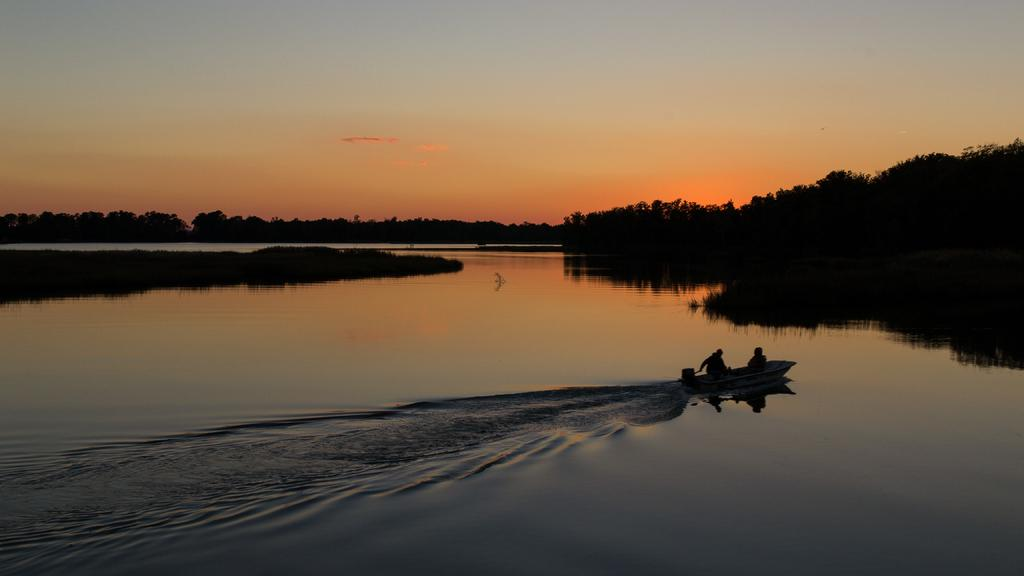What is at the bottom of the image? There is water at the bottom of the image. What can be seen on the right side of the image? There is a boat on the right side of the image. What type of vegetation is visible in the background of the image? There are trees in the background of the image. What is visible at the top of the image? The sky is visible at the top of the image. How many chairs are present in the image? There are no chairs visible in the image. Is there a hose connected to the boat in the image? There is no hose present in the image. 